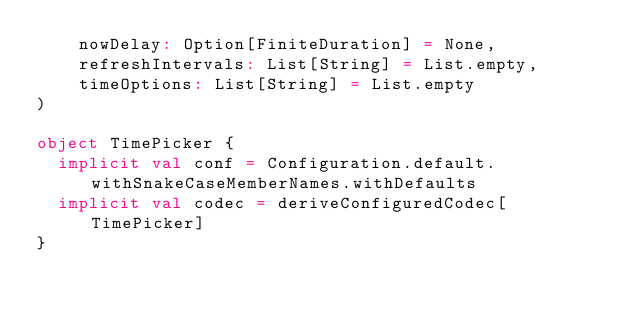<code> <loc_0><loc_0><loc_500><loc_500><_Scala_>    nowDelay: Option[FiniteDuration] = None,
    refreshIntervals: List[String] = List.empty,
    timeOptions: List[String] = List.empty
)

object TimePicker {
  implicit val conf = Configuration.default.withSnakeCaseMemberNames.withDefaults
  implicit val codec = deriveConfiguredCodec[TimePicker]
}
</code> 